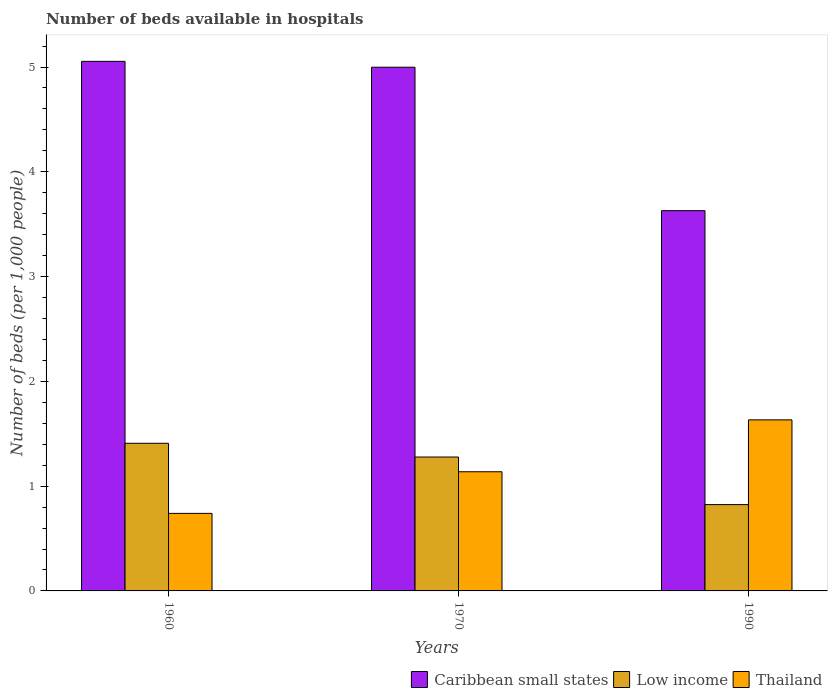How many different coloured bars are there?
Ensure brevity in your answer.  3. Are the number of bars per tick equal to the number of legend labels?
Ensure brevity in your answer.  Yes. What is the number of beds in the hospiatls of in Low income in 1960?
Your answer should be compact. 1.41. Across all years, what is the maximum number of beds in the hospiatls of in Caribbean small states?
Keep it short and to the point. 5.05. Across all years, what is the minimum number of beds in the hospiatls of in Caribbean small states?
Your answer should be very brief. 3.63. In which year was the number of beds in the hospiatls of in Low income minimum?
Your response must be concise. 1990. What is the total number of beds in the hospiatls of in Low income in the graph?
Your response must be concise. 3.51. What is the difference between the number of beds in the hospiatls of in Low income in 1960 and that in 1970?
Your answer should be compact. 0.13. What is the difference between the number of beds in the hospiatls of in Caribbean small states in 1970 and the number of beds in the hospiatls of in Thailand in 1990?
Make the answer very short. 3.37. What is the average number of beds in the hospiatls of in Caribbean small states per year?
Ensure brevity in your answer.  4.56. In the year 1960, what is the difference between the number of beds in the hospiatls of in Caribbean small states and number of beds in the hospiatls of in Thailand?
Your answer should be very brief. 4.31. What is the ratio of the number of beds in the hospiatls of in Thailand in 1960 to that in 1990?
Your answer should be very brief. 0.45. Is the difference between the number of beds in the hospiatls of in Caribbean small states in 1960 and 1970 greater than the difference between the number of beds in the hospiatls of in Thailand in 1960 and 1970?
Provide a short and direct response. Yes. What is the difference between the highest and the second highest number of beds in the hospiatls of in Caribbean small states?
Make the answer very short. 0.06. What is the difference between the highest and the lowest number of beds in the hospiatls of in Thailand?
Make the answer very short. 0.89. What does the 1st bar from the left in 1960 represents?
Offer a very short reply. Caribbean small states. What does the 1st bar from the right in 1970 represents?
Provide a short and direct response. Thailand. How many bars are there?
Ensure brevity in your answer.  9. Are all the bars in the graph horizontal?
Offer a terse response. No. Are the values on the major ticks of Y-axis written in scientific E-notation?
Offer a terse response. No. Does the graph contain any zero values?
Your response must be concise. No. Where does the legend appear in the graph?
Offer a terse response. Bottom right. What is the title of the graph?
Keep it short and to the point. Number of beds available in hospitals. Does "Central Europe" appear as one of the legend labels in the graph?
Your answer should be compact. No. What is the label or title of the Y-axis?
Offer a terse response. Number of beds (per 1,0 people). What is the Number of beds (per 1,000 people) in Caribbean small states in 1960?
Your answer should be compact. 5.05. What is the Number of beds (per 1,000 people) in Low income in 1960?
Your response must be concise. 1.41. What is the Number of beds (per 1,000 people) in Thailand in 1960?
Offer a very short reply. 0.74. What is the Number of beds (per 1,000 people) of Caribbean small states in 1970?
Make the answer very short. 5. What is the Number of beds (per 1,000 people) in Low income in 1970?
Offer a terse response. 1.28. What is the Number of beds (per 1,000 people) of Thailand in 1970?
Provide a succinct answer. 1.14. What is the Number of beds (per 1,000 people) in Caribbean small states in 1990?
Provide a short and direct response. 3.63. What is the Number of beds (per 1,000 people) in Low income in 1990?
Provide a short and direct response. 0.82. What is the Number of beds (per 1,000 people) of Thailand in 1990?
Provide a short and direct response. 1.63. Across all years, what is the maximum Number of beds (per 1,000 people) of Caribbean small states?
Offer a terse response. 5.05. Across all years, what is the maximum Number of beds (per 1,000 people) of Low income?
Provide a succinct answer. 1.41. Across all years, what is the maximum Number of beds (per 1,000 people) of Thailand?
Your response must be concise. 1.63. Across all years, what is the minimum Number of beds (per 1,000 people) in Caribbean small states?
Provide a short and direct response. 3.63. Across all years, what is the minimum Number of beds (per 1,000 people) of Low income?
Keep it short and to the point. 0.82. Across all years, what is the minimum Number of beds (per 1,000 people) in Thailand?
Your answer should be compact. 0.74. What is the total Number of beds (per 1,000 people) in Caribbean small states in the graph?
Provide a short and direct response. 13.68. What is the total Number of beds (per 1,000 people) of Low income in the graph?
Give a very brief answer. 3.51. What is the total Number of beds (per 1,000 people) in Thailand in the graph?
Offer a terse response. 3.51. What is the difference between the Number of beds (per 1,000 people) of Caribbean small states in 1960 and that in 1970?
Offer a terse response. 0.06. What is the difference between the Number of beds (per 1,000 people) of Low income in 1960 and that in 1970?
Your answer should be very brief. 0.13. What is the difference between the Number of beds (per 1,000 people) in Thailand in 1960 and that in 1970?
Provide a short and direct response. -0.4. What is the difference between the Number of beds (per 1,000 people) in Caribbean small states in 1960 and that in 1990?
Give a very brief answer. 1.43. What is the difference between the Number of beds (per 1,000 people) in Low income in 1960 and that in 1990?
Offer a terse response. 0.59. What is the difference between the Number of beds (per 1,000 people) of Thailand in 1960 and that in 1990?
Make the answer very short. -0.89. What is the difference between the Number of beds (per 1,000 people) in Caribbean small states in 1970 and that in 1990?
Offer a terse response. 1.37. What is the difference between the Number of beds (per 1,000 people) in Low income in 1970 and that in 1990?
Offer a terse response. 0.45. What is the difference between the Number of beds (per 1,000 people) in Thailand in 1970 and that in 1990?
Offer a terse response. -0.5. What is the difference between the Number of beds (per 1,000 people) in Caribbean small states in 1960 and the Number of beds (per 1,000 people) in Low income in 1970?
Ensure brevity in your answer.  3.78. What is the difference between the Number of beds (per 1,000 people) of Caribbean small states in 1960 and the Number of beds (per 1,000 people) of Thailand in 1970?
Your response must be concise. 3.92. What is the difference between the Number of beds (per 1,000 people) in Low income in 1960 and the Number of beds (per 1,000 people) in Thailand in 1970?
Your answer should be compact. 0.27. What is the difference between the Number of beds (per 1,000 people) of Caribbean small states in 1960 and the Number of beds (per 1,000 people) of Low income in 1990?
Your answer should be very brief. 4.23. What is the difference between the Number of beds (per 1,000 people) in Caribbean small states in 1960 and the Number of beds (per 1,000 people) in Thailand in 1990?
Give a very brief answer. 3.42. What is the difference between the Number of beds (per 1,000 people) of Low income in 1960 and the Number of beds (per 1,000 people) of Thailand in 1990?
Keep it short and to the point. -0.22. What is the difference between the Number of beds (per 1,000 people) in Caribbean small states in 1970 and the Number of beds (per 1,000 people) in Low income in 1990?
Offer a terse response. 4.17. What is the difference between the Number of beds (per 1,000 people) of Caribbean small states in 1970 and the Number of beds (per 1,000 people) of Thailand in 1990?
Make the answer very short. 3.37. What is the difference between the Number of beds (per 1,000 people) of Low income in 1970 and the Number of beds (per 1,000 people) of Thailand in 1990?
Offer a very short reply. -0.35. What is the average Number of beds (per 1,000 people) in Caribbean small states per year?
Your answer should be compact. 4.56. What is the average Number of beds (per 1,000 people) in Low income per year?
Give a very brief answer. 1.17. What is the average Number of beds (per 1,000 people) in Thailand per year?
Make the answer very short. 1.17. In the year 1960, what is the difference between the Number of beds (per 1,000 people) of Caribbean small states and Number of beds (per 1,000 people) of Low income?
Your response must be concise. 3.65. In the year 1960, what is the difference between the Number of beds (per 1,000 people) in Caribbean small states and Number of beds (per 1,000 people) in Thailand?
Ensure brevity in your answer.  4.31. In the year 1960, what is the difference between the Number of beds (per 1,000 people) in Low income and Number of beds (per 1,000 people) in Thailand?
Your response must be concise. 0.67. In the year 1970, what is the difference between the Number of beds (per 1,000 people) in Caribbean small states and Number of beds (per 1,000 people) in Low income?
Your answer should be very brief. 3.72. In the year 1970, what is the difference between the Number of beds (per 1,000 people) in Caribbean small states and Number of beds (per 1,000 people) in Thailand?
Your answer should be very brief. 3.86. In the year 1970, what is the difference between the Number of beds (per 1,000 people) in Low income and Number of beds (per 1,000 people) in Thailand?
Provide a succinct answer. 0.14. In the year 1990, what is the difference between the Number of beds (per 1,000 people) in Caribbean small states and Number of beds (per 1,000 people) in Low income?
Offer a very short reply. 2.81. In the year 1990, what is the difference between the Number of beds (per 1,000 people) of Caribbean small states and Number of beds (per 1,000 people) of Thailand?
Give a very brief answer. 2. In the year 1990, what is the difference between the Number of beds (per 1,000 people) of Low income and Number of beds (per 1,000 people) of Thailand?
Your answer should be compact. -0.81. What is the ratio of the Number of beds (per 1,000 people) of Caribbean small states in 1960 to that in 1970?
Keep it short and to the point. 1.01. What is the ratio of the Number of beds (per 1,000 people) of Low income in 1960 to that in 1970?
Provide a succinct answer. 1.1. What is the ratio of the Number of beds (per 1,000 people) in Thailand in 1960 to that in 1970?
Make the answer very short. 0.65. What is the ratio of the Number of beds (per 1,000 people) in Caribbean small states in 1960 to that in 1990?
Your answer should be compact. 1.39. What is the ratio of the Number of beds (per 1,000 people) in Low income in 1960 to that in 1990?
Your response must be concise. 1.71. What is the ratio of the Number of beds (per 1,000 people) of Thailand in 1960 to that in 1990?
Give a very brief answer. 0.45. What is the ratio of the Number of beds (per 1,000 people) in Caribbean small states in 1970 to that in 1990?
Provide a succinct answer. 1.38. What is the ratio of the Number of beds (per 1,000 people) of Low income in 1970 to that in 1990?
Make the answer very short. 1.55. What is the ratio of the Number of beds (per 1,000 people) of Thailand in 1970 to that in 1990?
Make the answer very short. 0.7. What is the difference between the highest and the second highest Number of beds (per 1,000 people) in Caribbean small states?
Give a very brief answer. 0.06. What is the difference between the highest and the second highest Number of beds (per 1,000 people) in Low income?
Provide a succinct answer. 0.13. What is the difference between the highest and the second highest Number of beds (per 1,000 people) of Thailand?
Your answer should be compact. 0.5. What is the difference between the highest and the lowest Number of beds (per 1,000 people) in Caribbean small states?
Ensure brevity in your answer.  1.43. What is the difference between the highest and the lowest Number of beds (per 1,000 people) of Low income?
Keep it short and to the point. 0.59. What is the difference between the highest and the lowest Number of beds (per 1,000 people) of Thailand?
Your answer should be very brief. 0.89. 